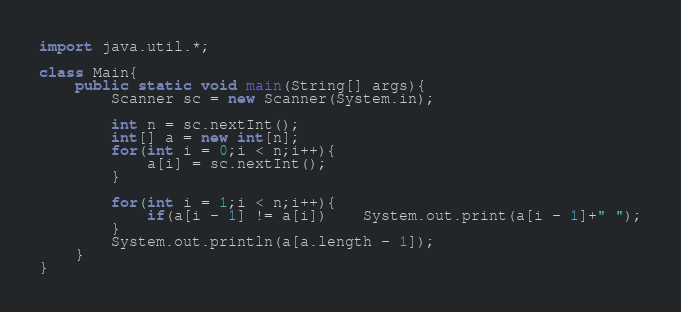Convert code to text. <code><loc_0><loc_0><loc_500><loc_500><_Java_>import java.util.*;

class Main{
    public static void main(String[] args){
        Scanner sc = new Scanner(System.in);

        int n = sc.nextInt();
        int[] a = new int[n];
        for(int i = 0;i < n;i++){
            a[i] = sc.nextInt();
        }

        for(int i = 1;i < n;i++){
            if(a[i - 1] != a[i])    System.out.print(a[i - 1]+" ");
        }
        System.out.println(a[a.length - 1]);
    }
}
</code> 